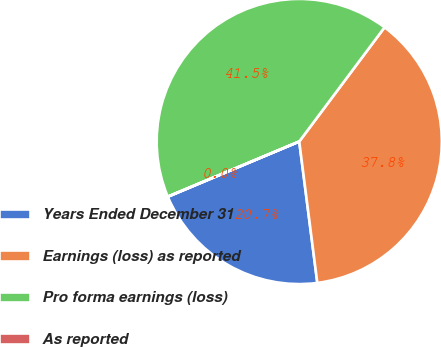Convert chart. <chart><loc_0><loc_0><loc_500><loc_500><pie_chart><fcel>Years Ended December 31<fcel>Earnings (loss) as reported<fcel>Pro forma earnings (loss)<fcel>As reported<nl><fcel>20.69%<fcel>37.76%<fcel>41.53%<fcel>0.02%<nl></chart> 